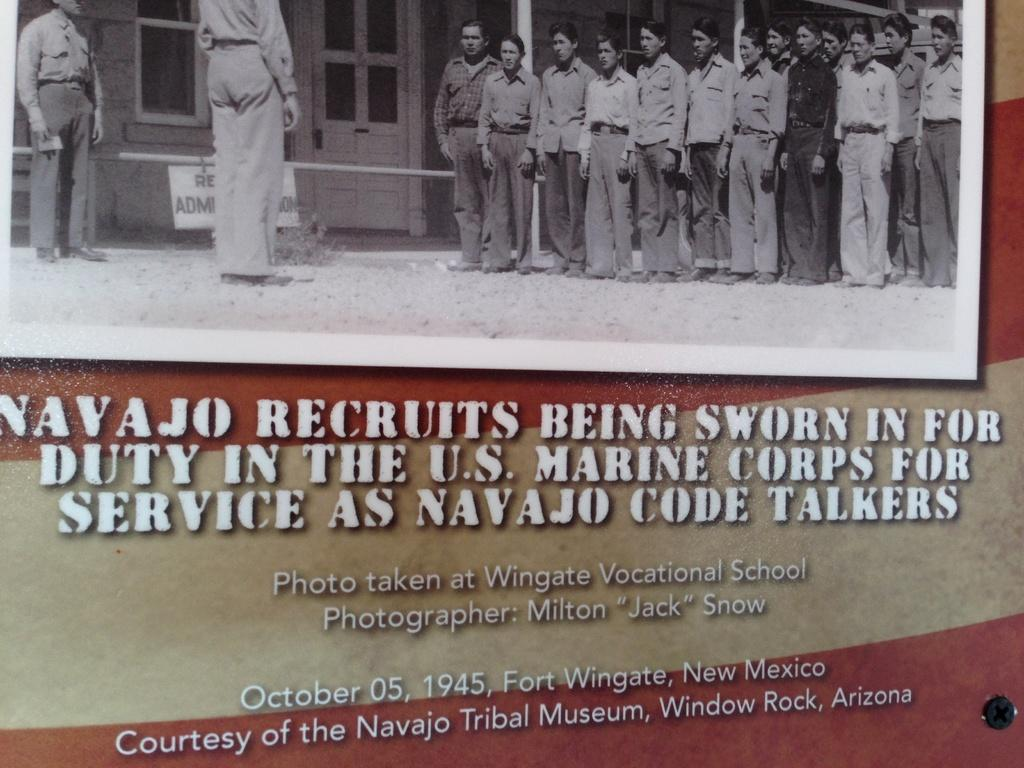What is depicted on the board in the image? There is a board with a picture of people in the image. Can you describe the people in the picture on the board? The picture on the board shows people standing. What type of structure can be seen in the image? There is a building with windows in the image. What other objects are present in the image? There are poles and text visible in the image. Can you tell me how many friends are swimming in the sea in the image? There is no sea or friends swimming in the image; it features a board with a picture of people standing, a building with windows, poles, and text. 